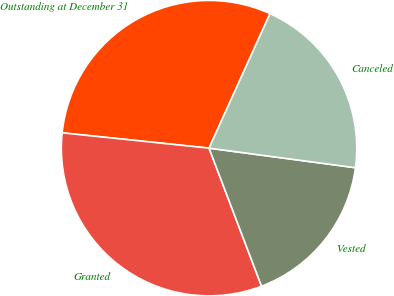<chart> <loc_0><loc_0><loc_500><loc_500><pie_chart><fcel>Outstanding at December 31<fcel>Granted<fcel>Vested<fcel>Canceled<nl><fcel>30.12%<fcel>32.44%<fcel>17.1%<fcel>20.34%<nl></chart> 